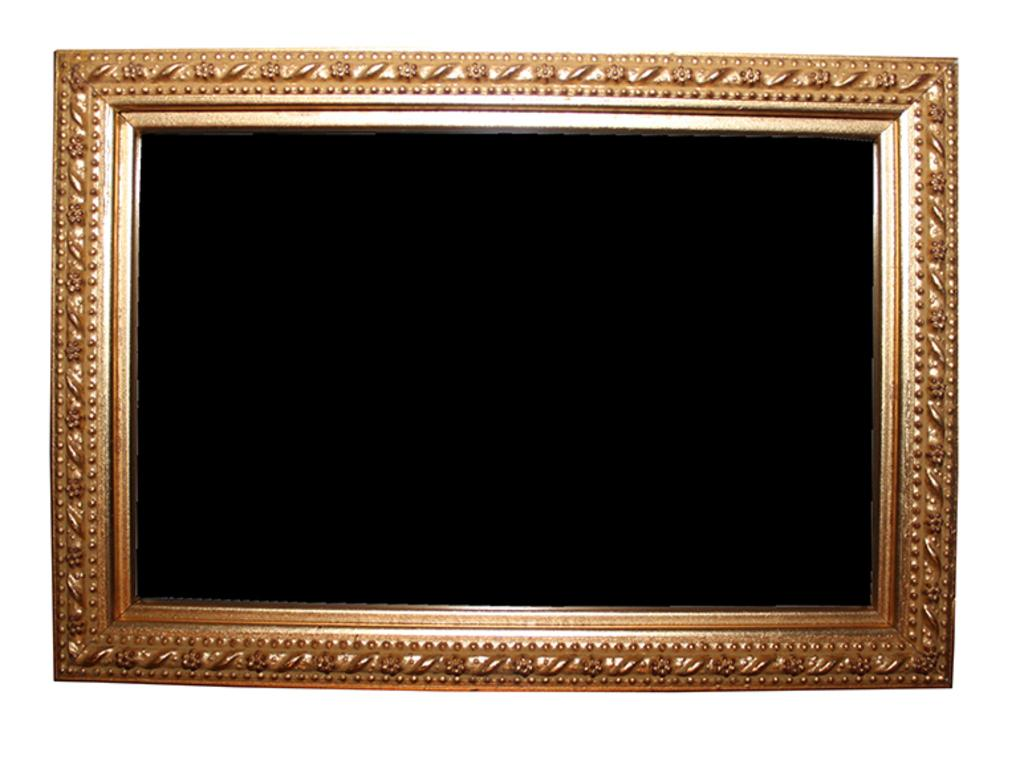What is the main subject of the image? The main subject of the image is an empty frame. What color is the background of the image? The background of the image is white. How many legs are visible in the image? There are no legs visible in the image, as it only features an empty frame against a white background. 